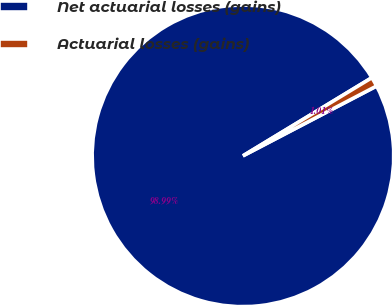Convert chart to OTSL. <chart><loc_0><loc_0><loc_500><loc_500><pie_chart><fcel>Net actuarial losses (gains)<fcel>Actuarial losses (gains)<nl><fcel>98.99%<fcel>1.01%<nl></chart> 